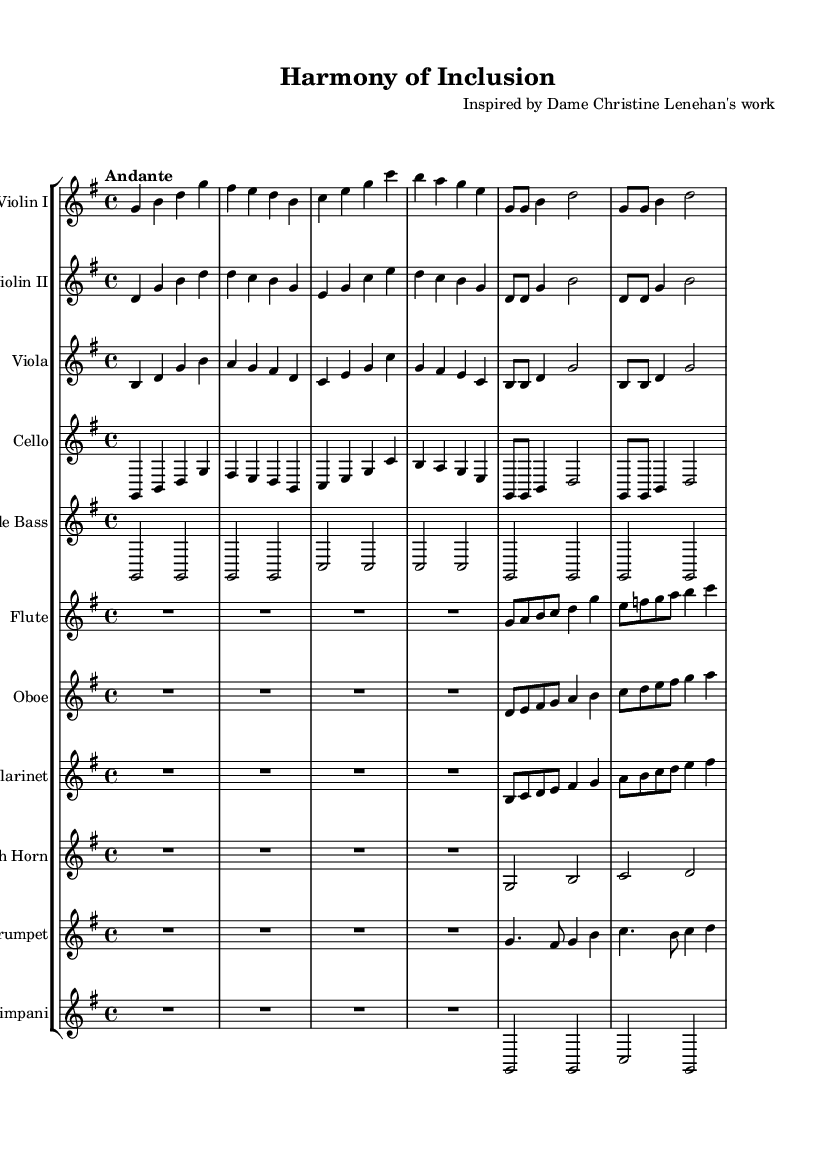What is the key signature of this music? The key signature indicates G major, as it has one sharp, which is F#. This can be identified by looking at the key signature marking at the beginning of the score.
Answer: G major What is the time signature of this music? The time signature is noted as 4/4, which means there are four beats per measure and a quarter note receives one beat. This is seen at the beginning of the score right after the key signature.
Answer: 4/4 What is the tempo marking of this composition? The tempo marking indicates "Andante," suggesting a moderately slow tempo. This is specified at the beginning of the score following the time signature.
Answer: Andante How many different instruments are used in this symphony? Counting the individual staves in the score, there are ten different instruments notated, which include strings, woodwinds, and brass. This is determined by identifying each line in the staff group labeled with an instrument name.
Answer: Ten Which instrument plays the highest pitch in this piece? The flute is the highest-pitched instrument, as it is notated to play higher notes than the other instrument parts when examining the range of pitches written on the staff.
Answer: Flute What is the rhythmic value of the longest note in the first measure of the flute part? In the first measure of the flute part, the longest note is a quarter note (g), as represented within the measure, signified by its note shape relative to the others.
Answer: Quarter note Which section of this symphony is characterized as a repeat? The repeating section is indicated with a "repeat unfold" marking, which shows that those measures should be played again. In this score, each repeated section appears within the string parts, primarily in the violin and cello.
Answer: Repeated sections 